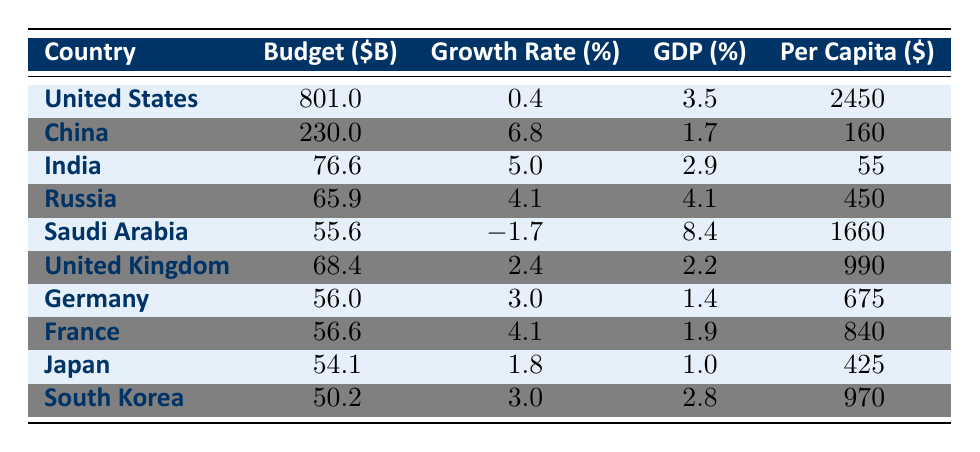What is the defense budget allocation for China in 2022? The table clearly indicates that the budget allocation for China is 230.0 billion dollars.
Answer: 230.0 billion dollars Which country has the highest per capita spending on defense? By comparing the per capita spending values in the table, the United States has the highest at 2450 dollars.
Answer: United States What is the total defense budget of the top three countries combined? The total is calculated by adding the budgets of the top three countries: United States (801.0) + China (230.0) + India (76.6) = 1107.6 billion dollars.
Answer: 1107.6 billion dollars Is Saudi Arabia's defense budget allocation increasing in 2022? The table shows that Saudi Arabia's growth rate is -1.7%, indicating a decrease in their defense budget.
Answer: No Which country allocates a larger percentage of its GDP to defense: India or Russia? The GDP percentages for India (2.9%) and Russia (4.1%) are compared; since 4.1% is greater than 2.9%, Russia allocates a larger percentage.
Answer: Russia What is the average defense budget allocation of the European countries listed in the table? The European countries are United Kingdom (68.4), Germany (56.0), France (56.6). Their total budget adds up to 181.0 billion dollars, and averaging this over 3 gives 181.0/3 = 60.33 billion dollars.
Answer: 60.33 billion dollars Did any country experience a negative growth rate in defense budget allocation in 2022? The table indicates that Saudi Arabia has a growth rate of -1.7%, confirming there is at least one country with a negative growth rate.
Answer: Yes Which country has the lowest defense budget allocation in 2022 among the top ten? By scanning through the budget allocations, South Korea has the lowest budget at 50.2 billion dollars.
Answer: South Korea 